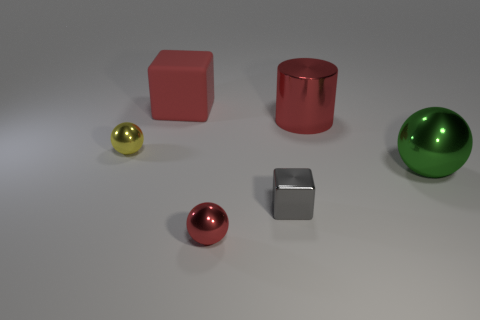Add 1 small red balls. How many objects exist? 7 Subtract all green spheres. How many spheres are left? 2 Subtract all red blocks. How many blocks are left? 1 Subtract all blocks. How many objects are left? 4 Subtract 1 balls. How many balls are left? 2 Add 5 tiny shiny spheres. How many tiny shiny spheres are left? 7 Add 4 large green spheres. How many large green spheres exist? 5 Subtract 0 blue balls. How many objects are left? 6 Subtract all brown cubes. Subtract all blue cylinders. How many cubes are left? 2 Subtract all gray cylinders. How many blue cubes are left? 0 